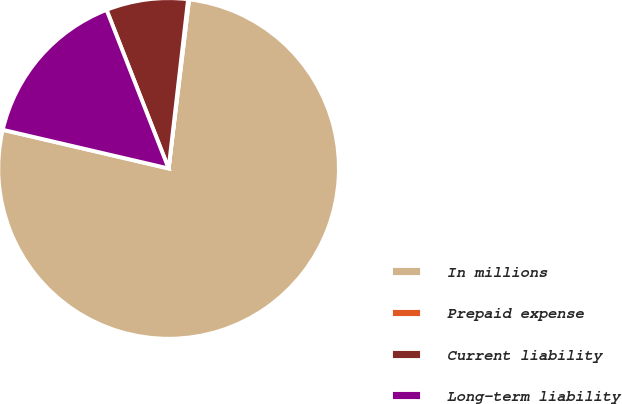Convert chart. <chart><loc_0><loc_0><loc_500><loc_500><pie_chart><fcel>In millions<fcel>Prepaid expense<fcel>Current liability<fcel>Long-term liability<nl><fcel>76.72%<fcel>0.1%<fcel>7.76%<fcel>15.42%<nl></chart> 